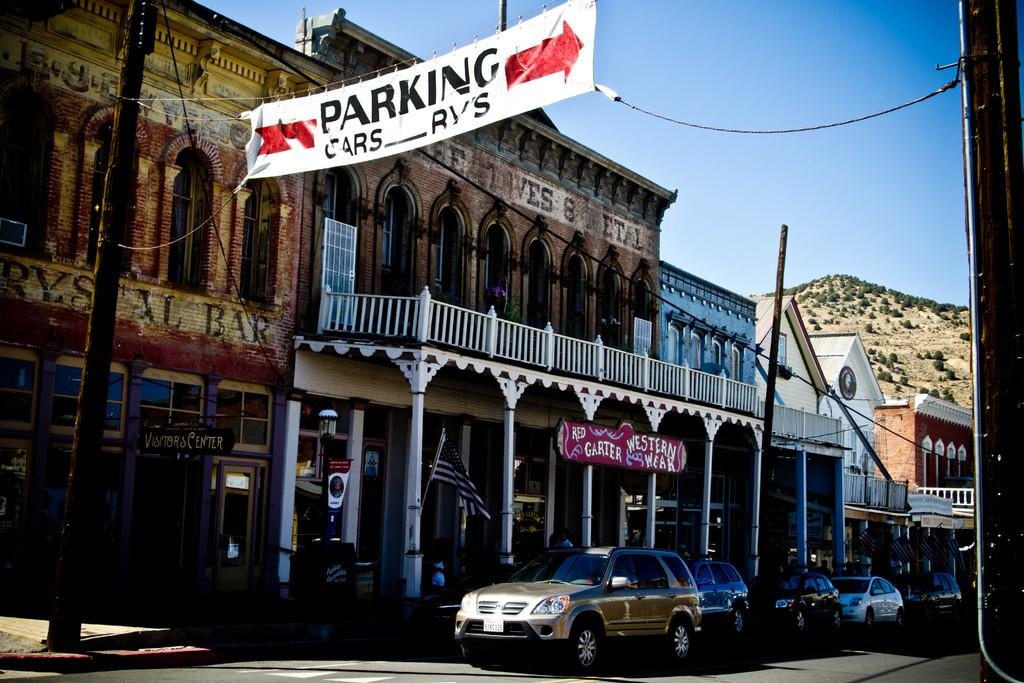<image>
Offer a succinct explanation of the picture presented. A banner promoting Red Garter Western Week is over a storefront. 